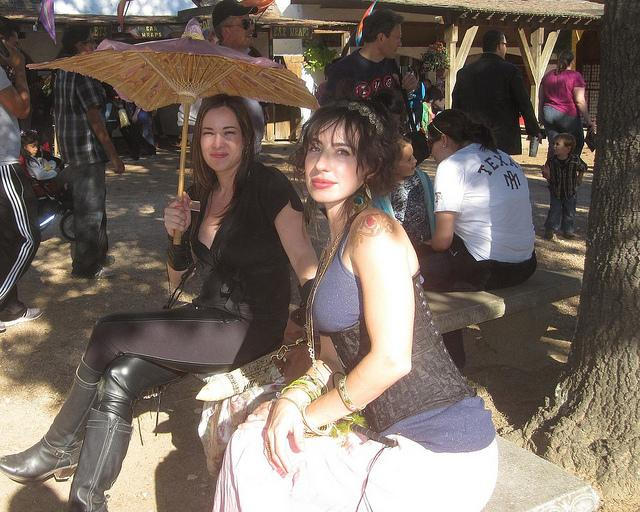The umbrella is made of what material? straw 